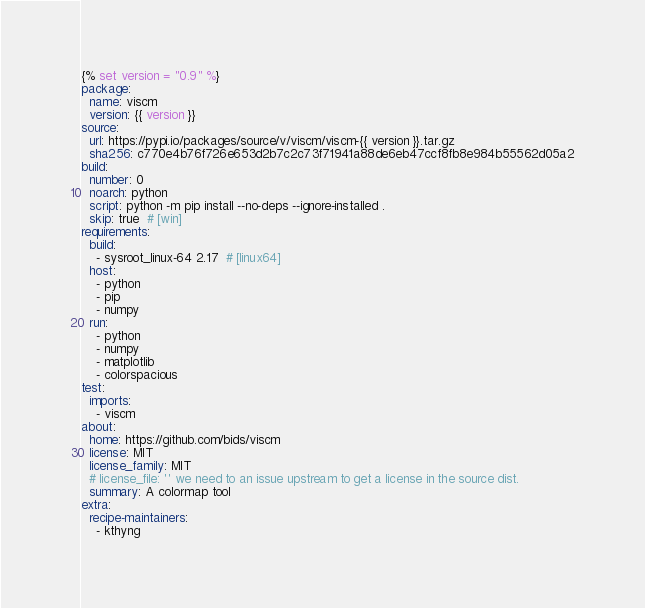Convert code to text. <code><loc_0><loc_0><loc_500><loc_500><_YAML_>{% set version = "0.9" %}
package:
  name: viscm
  version: {{ version }}
source:
  url: https://pypi.io/packages/source/v/viscm/viscm-{{ version }}.tar.gz
  sha256: c770e4b76f726e653d2b7c2c73f71941a88de6eb47ccf8fb8e984b55562d05a2
build:
  number: 0
  noarch: python
  script: python -m pip install --no-deps --ignore-installed .
  skip: true  # [win]
requirements:
  build:
    - sysroot_linux-64 2.17  # [linux64]
  host:
    - python
    - pip
    - numpy
  run:
    - python
    - numpy
    - matplotlib
    - colorspacious
test:
  imports:
    - viscm
about:
  home: https://github.com/bids/viscm
  license: MIT
  license_family: MIT
  # license_file: '' we need to an issue upstream to get a license in the source dist.
  summary: A colormap tool
extra:
  recipe-maintainers:
    - kthyng
</code> 